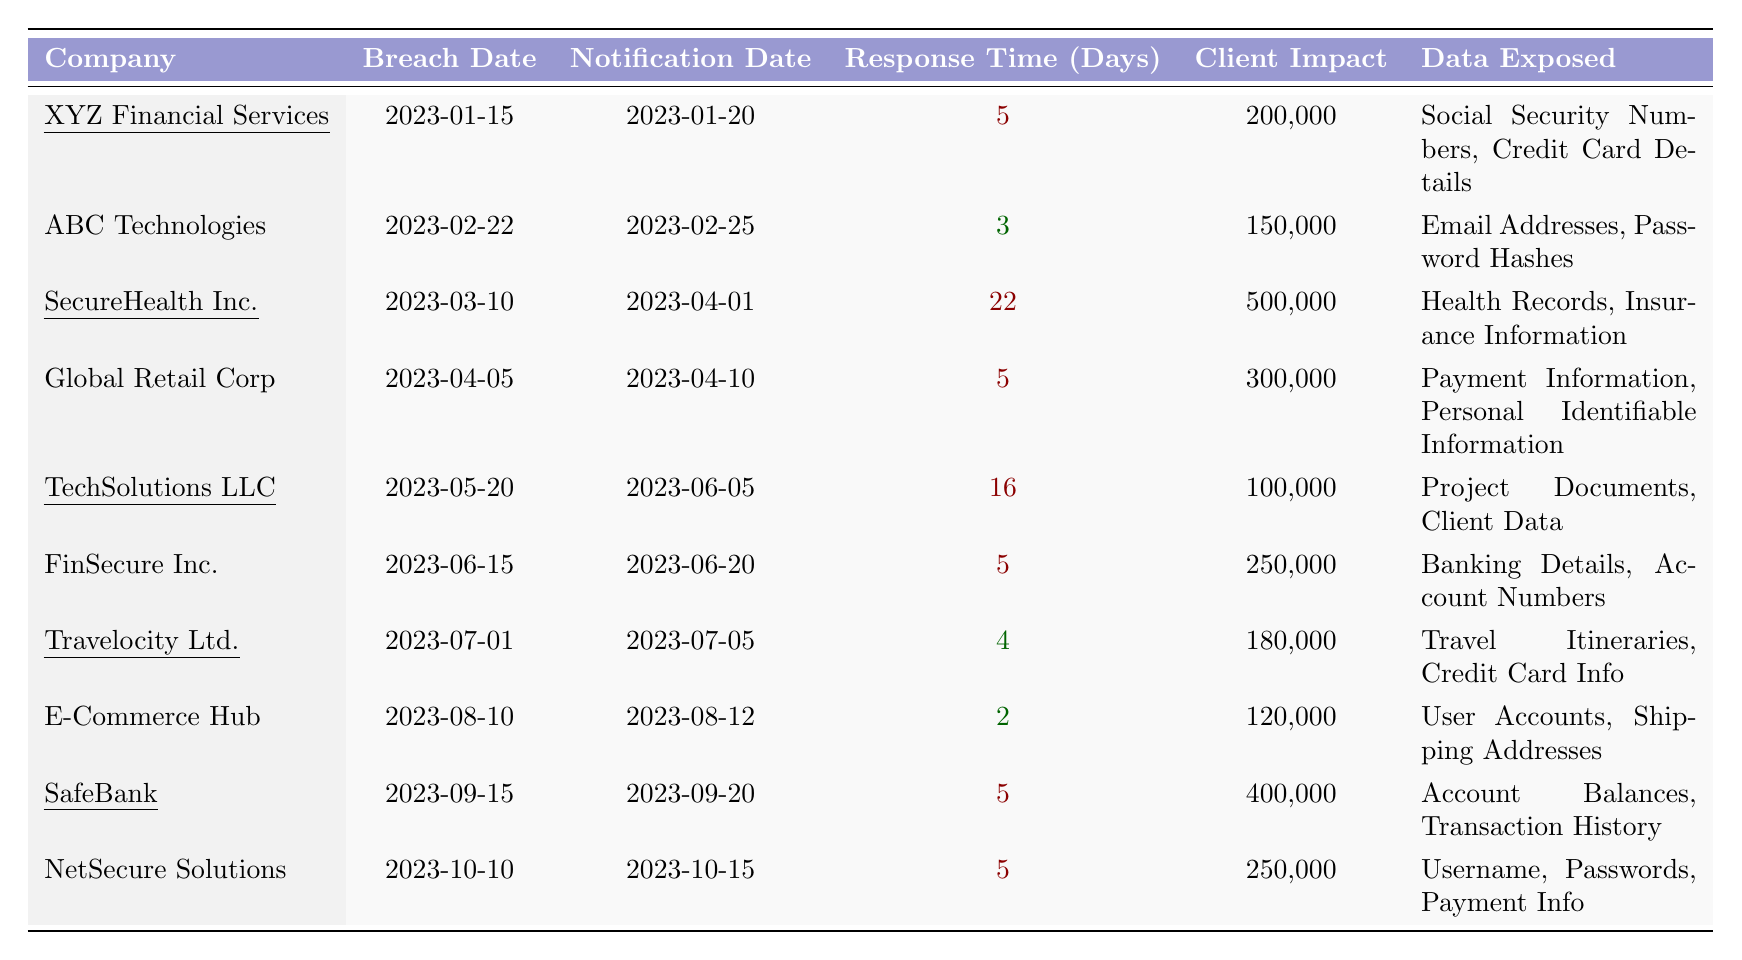What is the response time of XYZ Financial Services? The response time for XYZ Financial Services is found in the table under the "Response Time (Days)" column, which indicates it is 5 days.
Answer: 5 days How many clients were impacted by the breach at SecureHealth Inc.? The client impact for SecureHealth Inc. is listed as 500,000 clients in the "Client Impact" column of the table.
Answer: 500,000 clients Which company had the longest response time? To determine the longest response time, we examine the "Response Time (Days)" column and find that SecureHealth Inc. has the longest response time of 22 days.
Answer: SecureHealth Inc What is the average client impact across all companies in the table? To calculate the average client impact, sum the impacted clients: 200,000 + 150,000 + 500,000 + 300,000 + 100,000 + 250,000 + 180,000 + 120,000 + 400,000 + 250,000 = 2,650,000 clients. There are 10 companies, so the average is 2,650,000 / 10 = 265,000 clients.
Answer: 265,000 clients Did any company notify clients within 2 days of the breach? Checking the "Response Time (Days)" column, E-Commerce Hub notified clients within 2 days, which confirms that this statement is true.
Answer: Yes Which company exposed health records and how many clients were affected? The company that exposed health records is SecureHealth Inc., which impacted 500,000 clients as indicated in the "Data Exposed" and "Client Impact" columns.
Answer: SecureHealth Inc.; 500,000 clients What is the total number of clients impacted by all the breaches? By summing the total number of clients impacted: 200,000 + 150,000 + 500,000 + 300,000 + 100,000 + 250,000 + 180,000 + 120,000 + 400,000 + 250,000 = 2,650,000 clients.
Answer: 2,650,000 clients Which two companies had the quickest response times, and what were those times? The quickest response times can be found under the "Response Time (Days)" column, where E-Commerce Hub had a response time of 2 days and ABC Technologies had a response time of 3 days.
Answer: E-Commerce Hub (2 days) and ABC Technologies (3 days) Is there any company that took longer than 15 days to notify clients? Review the notification times, and it is clear that SecureHealth Inc. took 22 days to notify clients, confirming that this statement is true.
Answer: Yes How many companies had a response time of exactly 5 days? Identify the entries in the "Response Time (Days)" column that are equal to 5 days. The companies are XYZ Financial Services, Global Retail Corp, FinSecure Inc., SafeBank, and NetSecure Solutions, totaling 5 companies.
Answer: 5 companies 